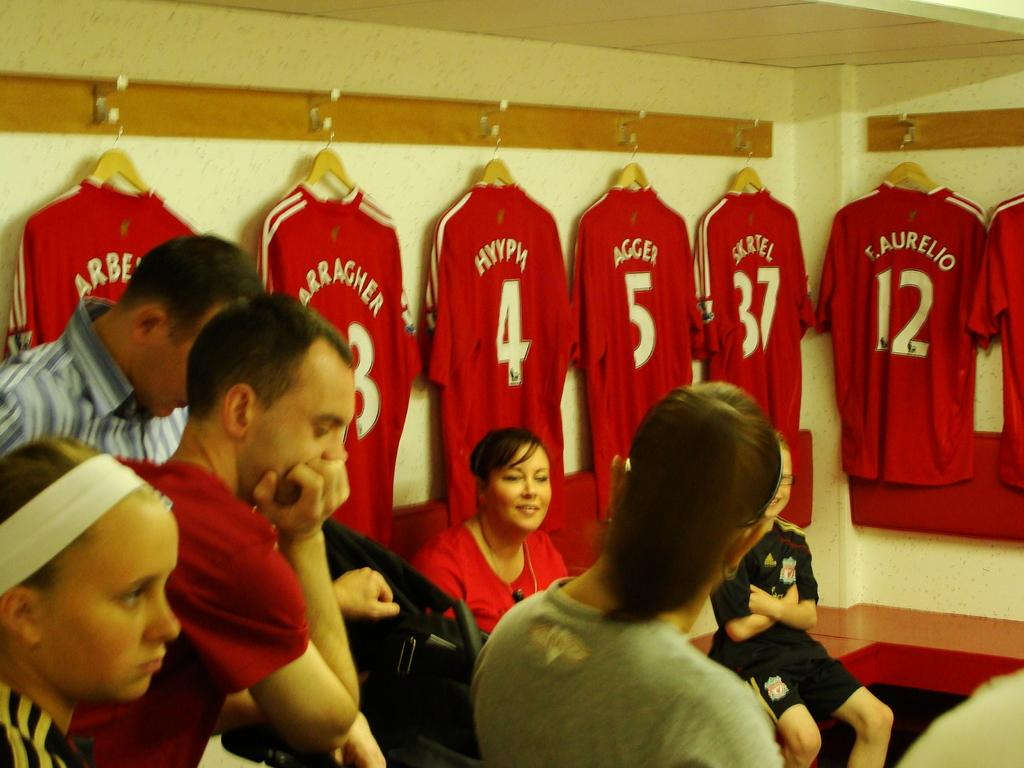<image>
Describe the image concisely. A group of people are in a locker room with jerseys hanging on the wall and one says Agger. 